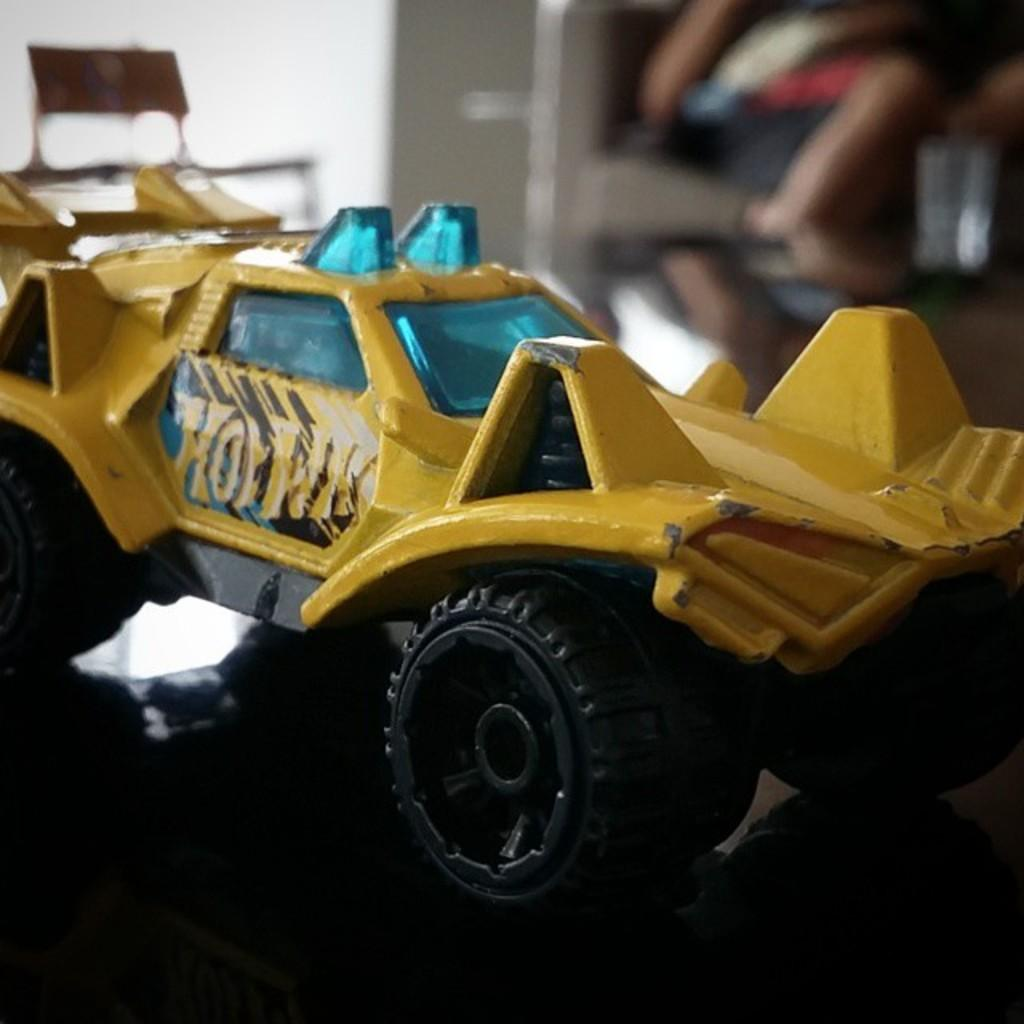What type of toy is in the image? There is a toy vehicle in the image. Where is the toy vehicle located? The toy vehicle is on a platform. Can you describe the background of the image? The background of the image is blurred. What else can be seen in the background of the image? There are objects visible in the background of the image. What advice does the toy vehicle give to the other toys in the image? There is no indication in the image that the toy vehicle is giving advice or interacting with other toys. 